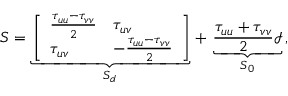<formula> <loc_0><loc_0><loc_500><loc_500>{ S } = \underbrace { \left [ \begin{array} { l l } { \frac { \tau _ { u u } - \tau _ { v v } } { 2 } } & { \tau _ { u v } } \\ { \tau _ { u v } } & { - \frac { \tau _ { u u } - \tau _ { v v } } { 2 } } \end{array} \right ] } _ { { S } _ { d } } \, + \, \underbrace { \frac { \tau _ { u u } + \tau _ { v v } } { 2 } { \mathcal { I } } } _ { { S } _ { 0 } } \, ,</formula> 